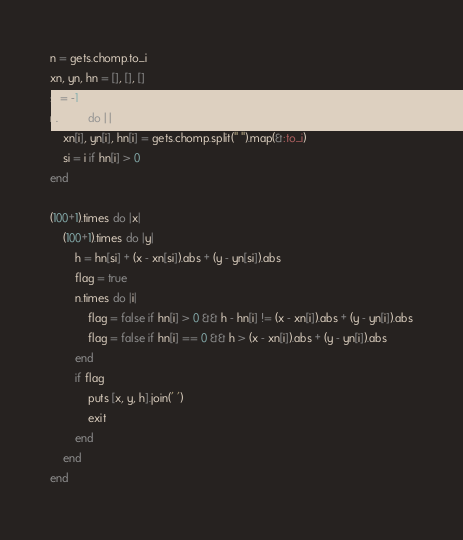Convert code to text. <code><loc_0><loc_0><loc_500><loc_500><_Ruby_>n = gets.chomp.to_i
xn, yn, hn = [], [], []
si = -1
n.times do |i|
    xn[i], yn[i], hn[i] = gets.chomp.split(" ").map(&:to_i)
    si = i if hn[i] > 0
end

(100+1).times do |x|
    (100+1).times do |y|
        h = hn[si] + (x - xn[si]).abs + (y - yn[si]).abs
        flag = true
        n.times do |i|
            flag = false if hn[i] > 0 && h - hn[i] != (x - xn[i]).abs + (y - yn[i]).abs
            flag = false if hn[i] == 0 && h > (x - xn[i]).abs + (y - yn[i]).abs
        end
        if flag
            puts [x, y, h].join(' ')
            exit
        end
    end
end</code> 